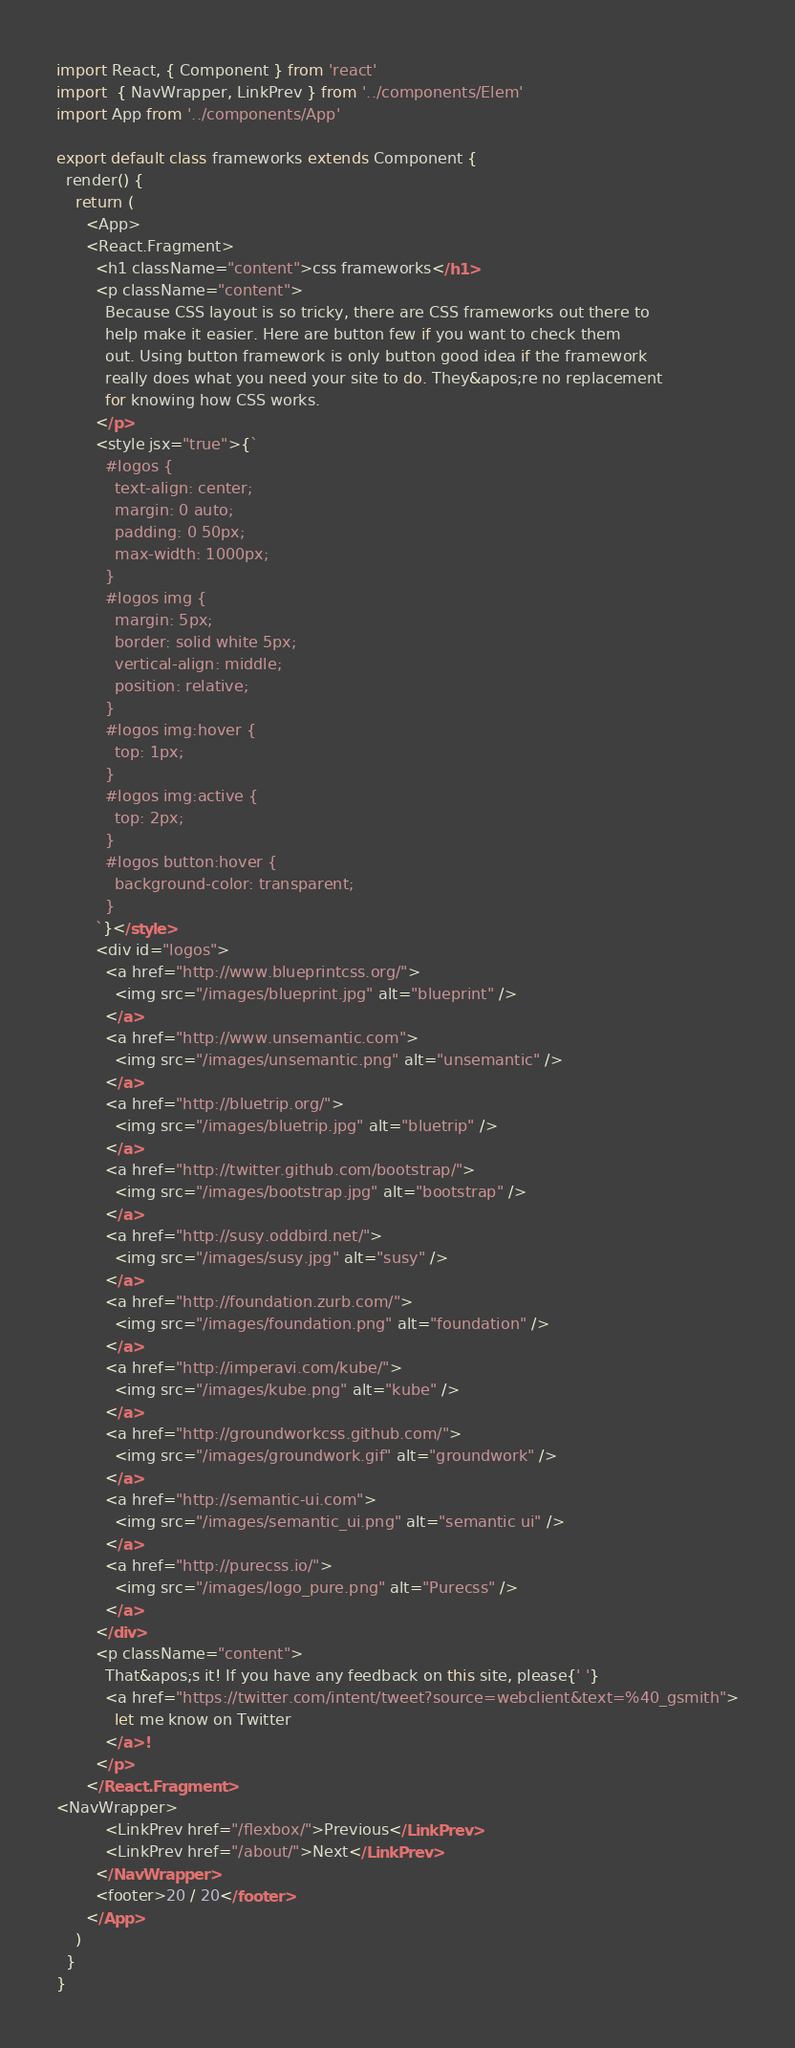<code> <loc_0><loc_0><loc_500><loc_500><_JavaScript_>import React, { Component } from 'react'
import  { NavWrapper, LinkPrev } from '../components/Elem'
import App from '../components/App'

export default class frameworks extends Component {
  render() {
    return (
      <App>
      <React.Fragment>
        <h1 className="content">css frameworks</h1>
        <p className="content">
          Because CSS layout is so tricky, there are CSS frameworks out there to
          help make it easier. Here are button few if you want to check them
          out. Using button framework is only button good idea if the framework
          really does what you need your site to do. They&apos;re no replacement
          for knowing how CSS works.
        </p>
        <style jsx="true">{`
          #logos {
            text-align: center;
            margin: 0 auto;
            padding: 0 50px;
            max-width: 1000px;
          }
          #logos img {
            margin: 5px;
            border: solid white 5px;
            vertical-align: middle;
            position: relative;
          }
          #logos img:hover {
            top: 1px;
          }
          #logos img:active {
            top: 2px;
          }
          #logos button:hover {
            background-color: transparent;
          }
        `}</style>
        <div id="logos">
          <a href="http://www.blueprintcss.org/">
            <img src="/images/blueprint.jpg" alt="blueprint" />
          </a>
          <a href="http://www.unsemantic.com">
            <img src="/images/unsemantic.png" alt="unsemantic" />
          </a>
          <a href="http://bluetrip.org/">
            <img src="/images/bluetrip.jpg" alt="bluetrip" />
          </a>
          <a href="http://twitter.github.com/bootstrap/">
            <img src="/images/bootstrap.jpg" alt="bootstrap" />
          </a>
          <a href="http://susy.oddbird.net/">
            <img src="/images/susy.jpg" alt="susy" />
          </a>
          <a href="http://foundation.zurb.com/">
            <img src="/images/foundation.png" alt="foundation" />
          </a>
          <a href="http://imperavi.com/kube/">
            <img src="/images/kube.png" alt="kube" />
          </a>
          <a href="http://groundworkcss.github.com/">
            <img src="/images/groundwork.gif" alt="groundwork" />
          </a>
          <a href="http://semantic-ui.com">
            <img src="/images/semantic_ui.png" alt="semantic ui" />
          </a>
          <a href="http://purecss.io/">
            <img src="/images/logo_pure.png" alt="Purecss" />
          </a>
        </div>
        <p className="content">
          That&apos;s it! If you have any feedback on this site, please{' '}
          <a href="https://twitter.com/intent/tweet?source=webclient&text=%40_gsmith">
            let me know on Twitter
          </a>!
        </p>
      </React.Fragment>
<NavWrapper>
          <LinkPrev href="/flexbox/">Previous</LinkPrev>
          <LinkPrev href="/about/">Next</LinkPrev>
        </NavWrapper>
        <footer>20 / 20</footer>
      </App>
    )
  }
}
</code> 